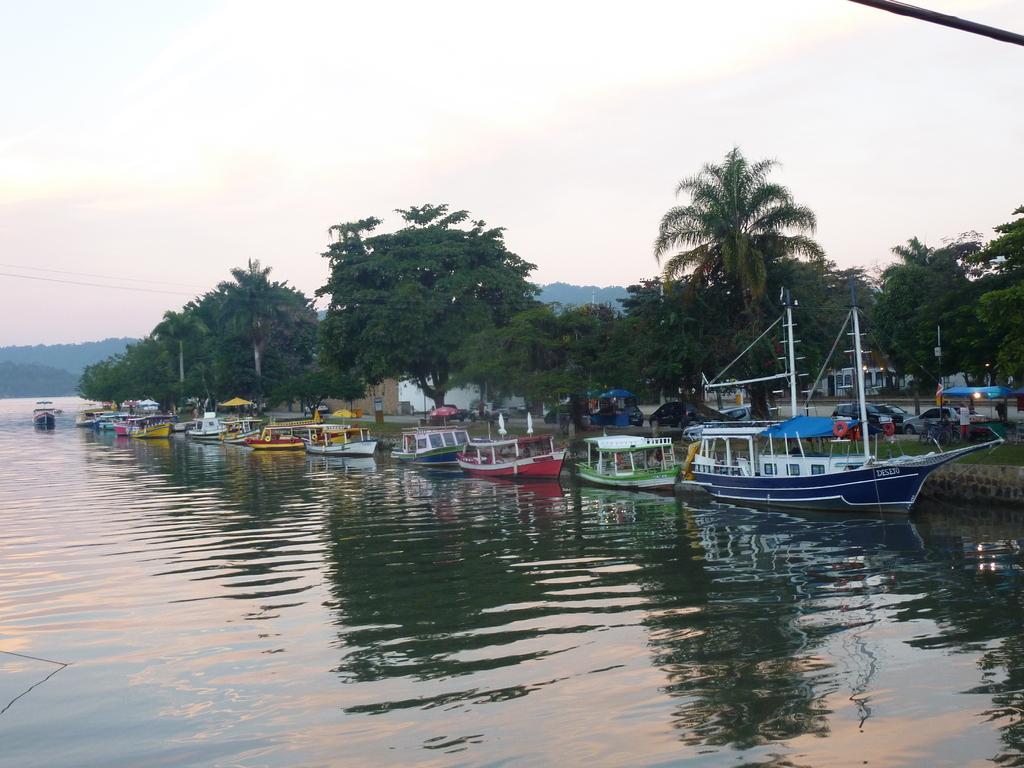Please provide a concise description of this image. In this image we can see a group of boats floating in the water. We can also see some vehicles, buildings, a group of trees and the sky which looks cloudy. 